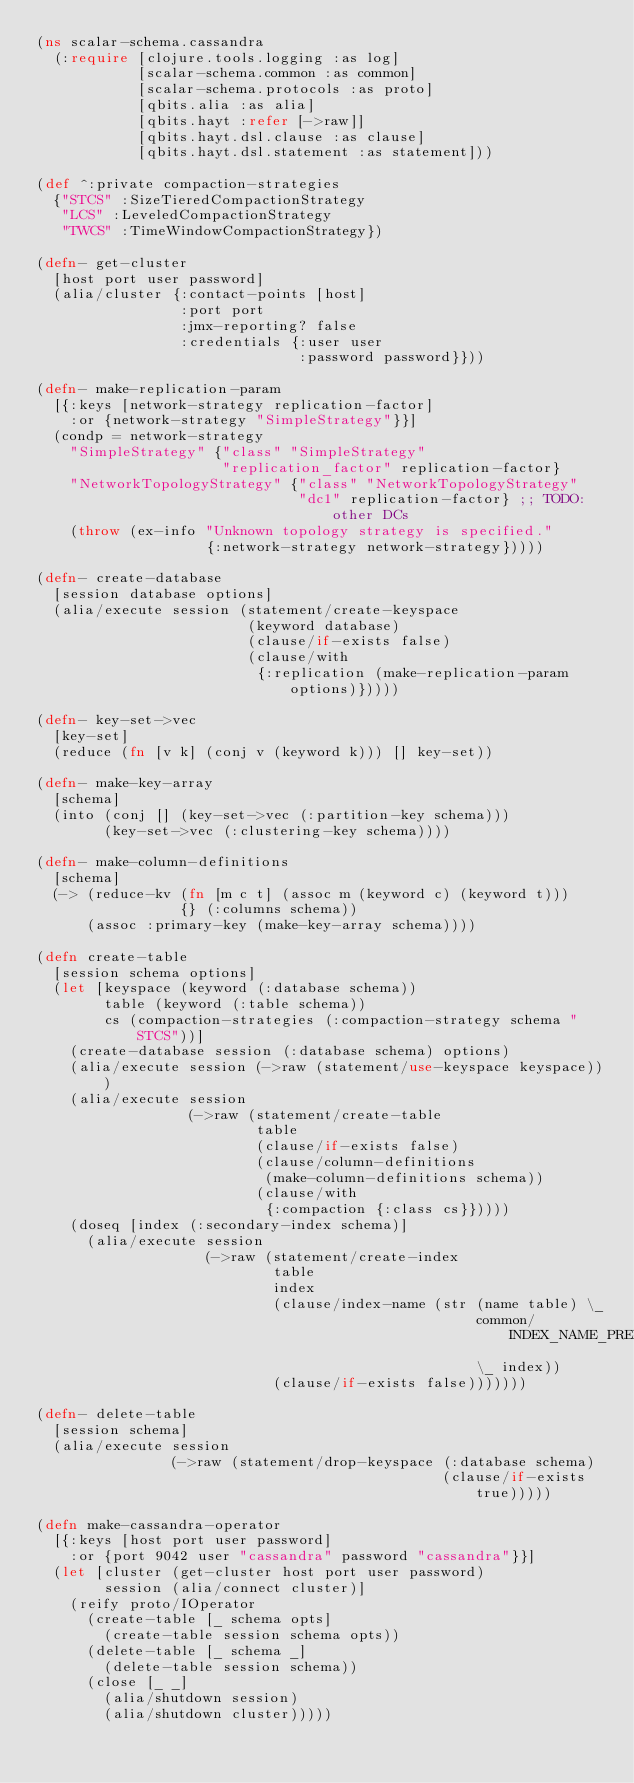<code> <loc_0><loc_0><loc_500><loc_500><_Clojure_>(ns scalar-schema.cassandra
  (:require [clojure.tools.logging :as log]
            [scalar-schema.common :as common]
            [scalar-schema.protocols :as proto]
            [qbits.alia :as alia]
            [qbits.hayt :refer [->raw]]
            [qbits.hayt.dsl.clause :as clause]
            [qbits.hayt.dsl.statement :as statement]))

(def ^:private compaction-strategies
  {"STCS" :SizeTieredCompactionStrategy
   "LCS" :LeveledCompactionStrategy
   "TWCS" :TimeWindowCompactionStrategy})

(defn- get-cluster
  [host port user password]
  (alia/cluster {:contact-points [host]
                 :port port
                 :jmx-reporting? false
                 :credentials {:user user
                               :password password}}))

(defn- make-replication-param
  [{:keys [network-strategy replication-factor]
    :or {network-strategy "SimpleStrategy"}}]
  (condp = network-strategy
    "SimpleStrategy" {"class" "SimpleStrategy"
                      "replication_factor" replication-factor}
    "NetworkTopologyStrategy" {"class" "NetworkTopologyStrategy"
                               "dc1" replication-factor} ;; TODO: other DCs
    (throw (ex-info "Unknown topology strategy is specified."
                    {:network-strategy network-strategy}))))

(defn- create-database
  [session database options]
  (alia/execute session (statement/create-keyspace
                         (keyword database)
                         (clause/if-exists false)
                         (clause/with
                          {:replication (make-replication-param options)}))))

(defn- key-set->vec
  [key-set]
  (reduce (fn [v k] (conj v (keyword k))) [] key-set))

(defn- make-key-array
  [schema]
  (into (conj [] (key-set->vec (:partition-key schema)))
        (key-set->vec (:clustering-key schema))))

(defn- make-column-definitions
  [schema]
  (-> (reduce-kv (fn [m c t] (assoc m (keyword c) (keyword t)))
                 {} (:columns schema))
      (assoc :primary-key (make-key-array schema))))

(defn create-table
  [session schema options]
  (let [keyspace (keyword (:database schema))
        table (keyword (:table schema))
        cs (compaction-strategies (:compaction-strategy schema "STCS"))]
    (create-database session (:database schema) options)
    (alia/execute session (->raw (statement/use-keyspace keyspace)))
    (alia/execute session
                  (->raw (statement/create-table
                          table
                          (clause/if-exists false)
                          (clause/column-definitions
                           (make-column-definitions schema))
                          (clause/with
                           {:compaction {:class cs}}))))
    (doseq [index (:secondary-index schema)]
      (alia/execute session
                    (->raw (statement/create-index
                            table
                            index
                            (clause/index-name (str (name table) \_
                                                    common/INDEX_NAME_PREFIX
                                                    \_ index))
                            (clause/if-exists false)))))))

(defn- delete-table
  [session schema]
  (alia/execute session
                (->raw (statement/drop-keyspace (:database schema)
                                                (clause/if-exists true)))))

(defn make-cassandra-operator
  [{:keys [host port user password]
    :or {port 9042 user "cassandra" password "cassandra"}}]
  (let [cluster (get-cluster host port user password)
        session (alia/connect cluster)]
    (reify proto/IOperator
      (create-table [_ schema opts]
        (create-table session schema opts))
      (delete-table [_ schema _]
        (delete-table session schema))
      (close [_ _]
        (alia/shutdown session)
        (alia/shutdown cluster)))))
</code> 